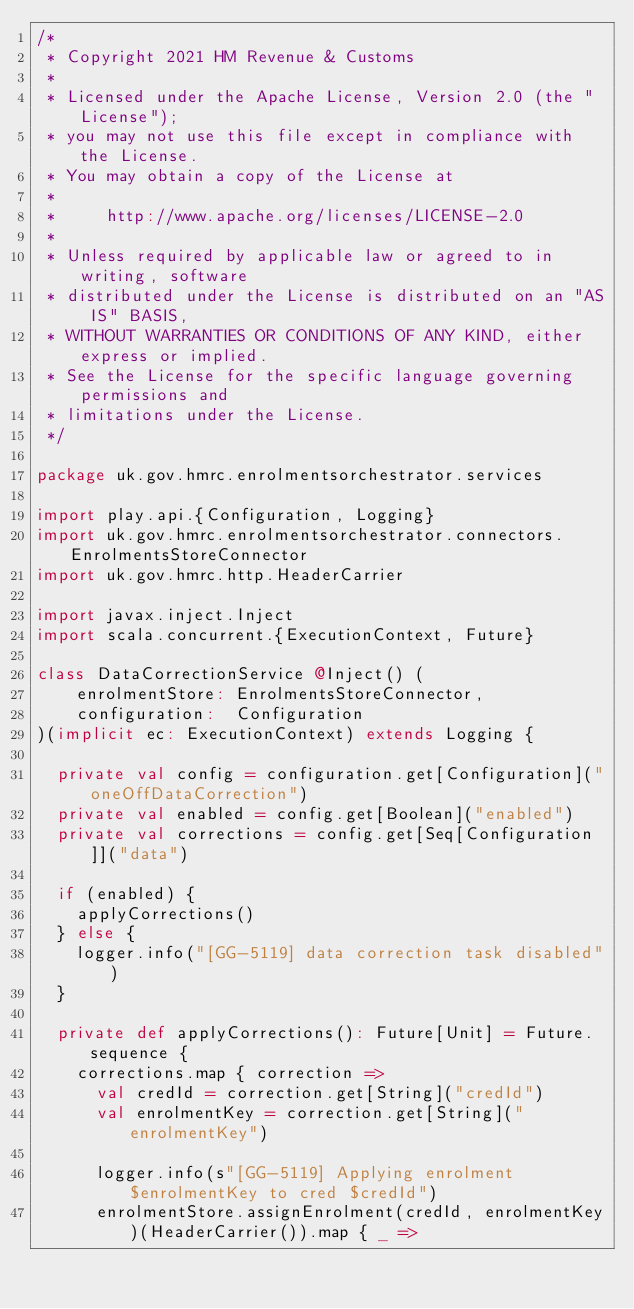Convert code to text. <code><loc_0><loc_0><loc_500><loc_500><_Scala_>/*
 * Copyright 2021 HM Revenue & Customs
 *
 * Licensed under the Apache License, Version 2.0 (the "License");
 * you may not use this file except in compliance with the License.
 * You may obtain a copy of the License at
 *
 *     http://www.apache.org/licenses/LICENSE-2.0
 *
 * Unless required by applicable law or agreed to in writing, software
 * distributed under the License is distributed on an "AS IS" BASIS,
 * WITHOUT WARRANTIES OR CONDITIONS OF ANY KIND, either express or implied.
 * See the License for the specific language governing permissions and
 * limitations under the License.
 */

package uk.gov.hmrc.enrolmentsorchestrator.services

import play.api.{Configuration, Logging}
import uk.gov.hmrc.enrolmentsorchestrator.connectors.EnrolmentsStoreConnector
import uk.gov.hmrc.http.HeaderCarrier

import javax.inject.Inject
import scala.concurrent.{ExecutionContext, Future}

class DataCorrectionService @Inject() (
    enrolmentStore: EnrolmentsStoreConnector,
    configuration:  Configuration
)(implicit ec: ExecutionContext) extends Logging {

  private val config = configuration.get[Configuration]("oneOffDataCorrection")
  private val enabled = config.get[Boolean]("enabled")
  private val corrections = config.get[Seq[Configuration]]("data")

  if (enabled) {
    applyCorrections()
  } else {
    logger.info("[GG-5119] data correction task disabled")
  }

  private def applyCorrections(): Future[Unit] = Future.sequence {
    corrections.map { correction =>
      val credId = correction.get[String]("credId")
      val enrolmentKey = correction.get[String]("enrolmentKey")

      logger.info(s"[GG-5119] Applying enrolment $enrolmentKey to cred $credId")
      enrolmentStore.assignEnrolment(credId, enrolmentKey)(HeaderCarrier()).map { _ =></code> 